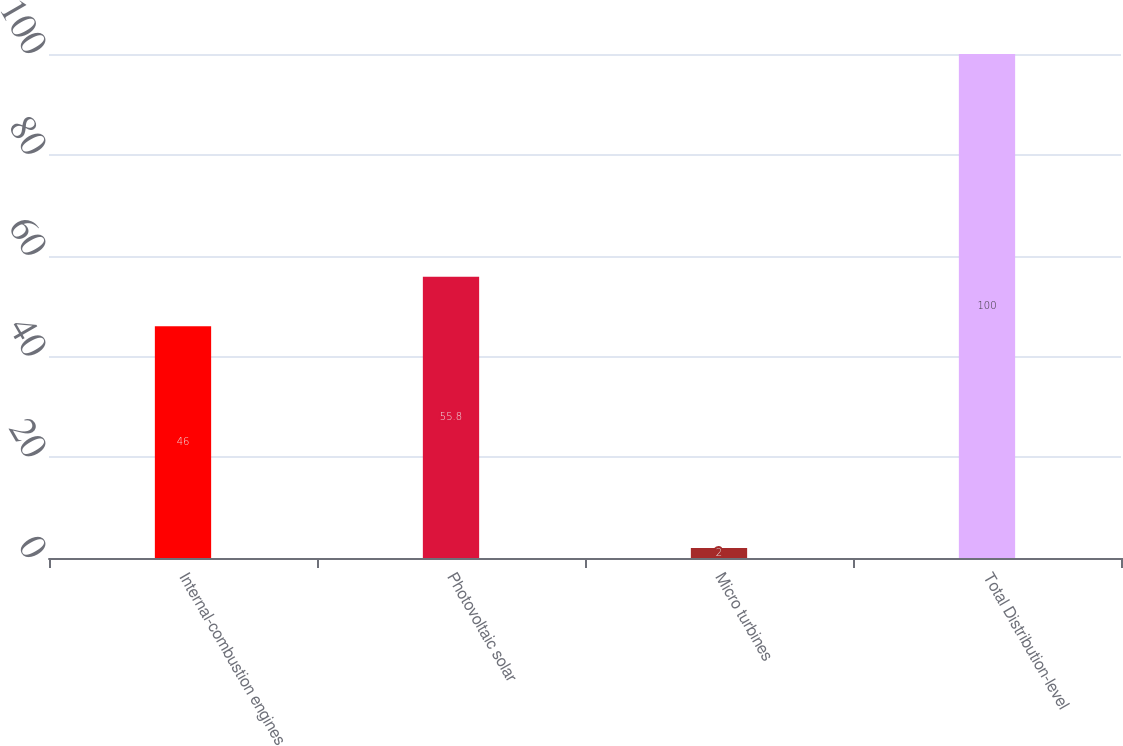Convert chart to OTSL. <chart><loc_0><loc_0><loc_500><loc_500><bar_chart><fcel>Internal-combustion engines<fcel>Photovoltaic solar<fcel>Micro turbines<fcel>Total Distribution-level<nl><fcel>46<fcel>55.8<fcel>2<fcel>100<nl></chart> 